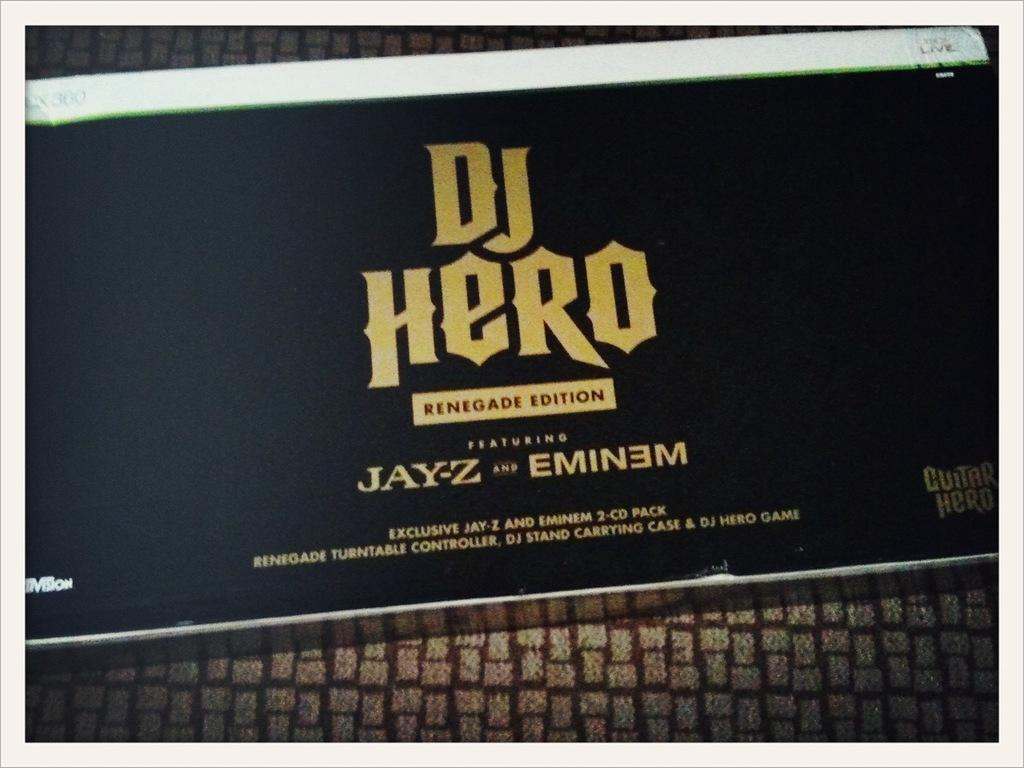<image>
Present a compact description of the photo's key features. the words DJ hero on a box with eminem 